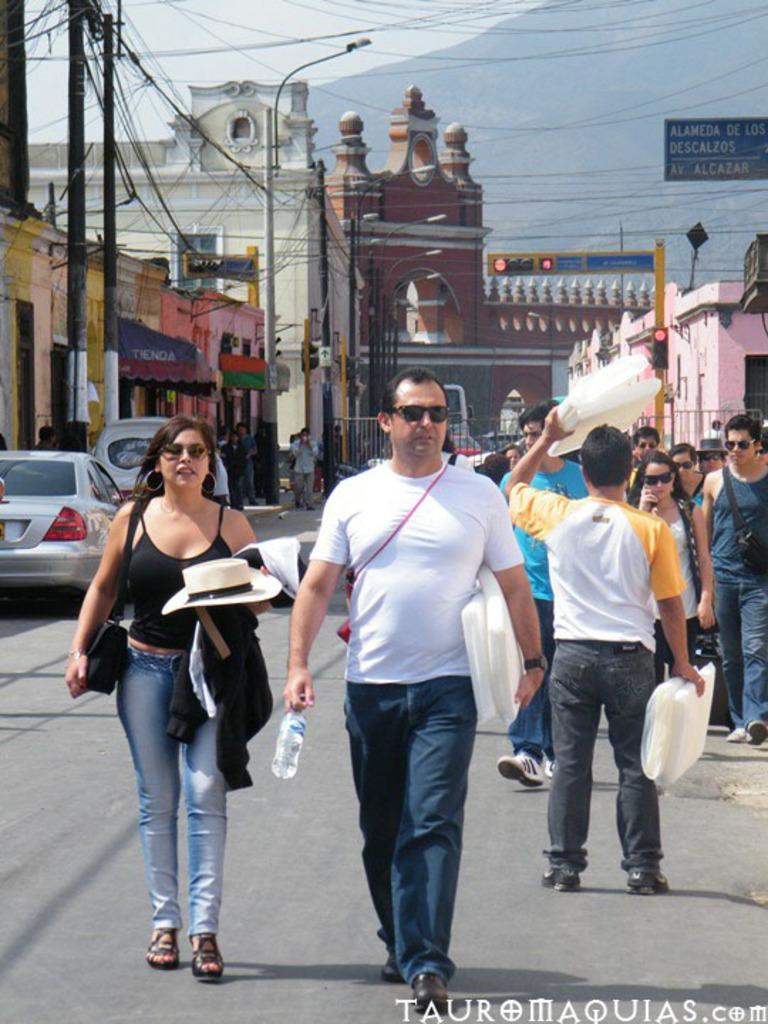In one or two sentences, can you explain what this image depicts? In the picture I can see a couple standing and holding few objects in their hands and there are few persons,vehicles,buildings,poles,wires behind them and there is a mountain in the background. 